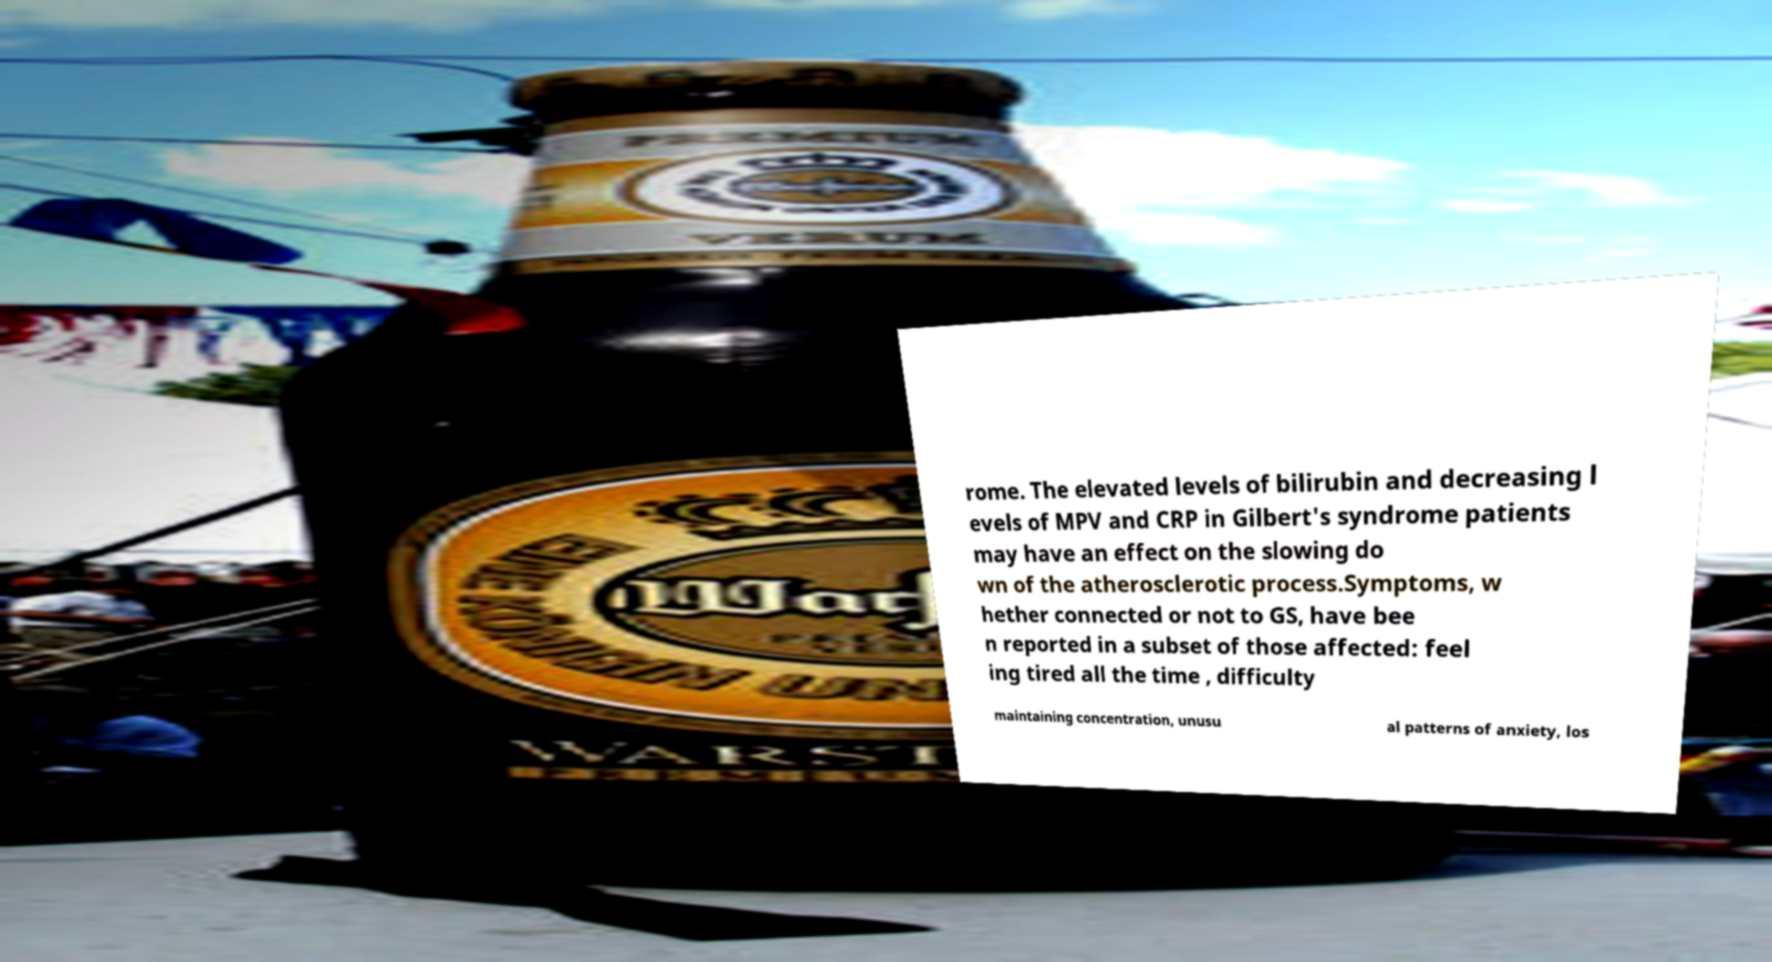Please identify and transcribe the text found in this image. rome. The elevated levels of bilirubin and decreasing l evels of MPV and CRP in Gilbert's syndrome patients may have an effect on the slowing do wn of the atherosclerotic process.Symptoms, w hether connected or not to GS, have bee n reported in a subset of those affected: feel ing tired all the time , difficulty maintaining concentration, unusu al patterns of anxiety, los 